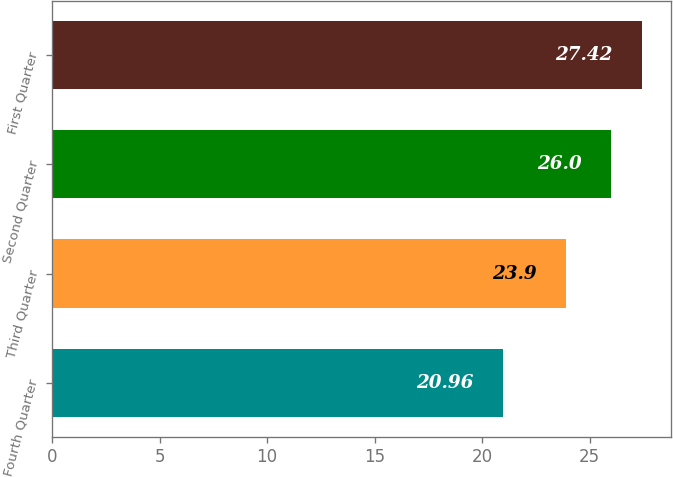<chart> <loc_0><loc_0><loc_500><loc_500><bar_chart><fcel>Fourth Quarter<fcel>Third Quarter<fcel>Second Quarter<fcel>First Quarter<nl><fcel>20.96<fcel>23.9<fcel>26<fcel>27.42<nl></chart> 